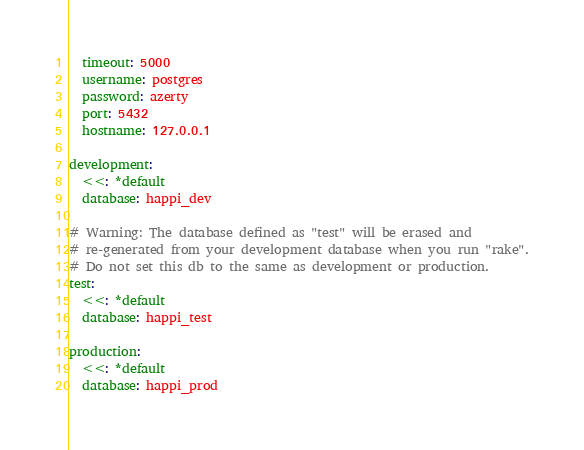<code> <loc_0><loc_0><loc_500><loc_500><_YAML_>  timeout: 5000
  username: postgres
  password: azerty
  port: 5432
  hostname: 127.0.0.1

development:
  <<: *default
  database: happi_dev

# Warning: The database defined as "test" will be erased and
# re-generated from your development database when you run "rake".
# Do not set this db to the same as development or production.
test:
  <<: *default
  database: happi_test

production:
  <<: *default
  database: happi_prod
</code> 